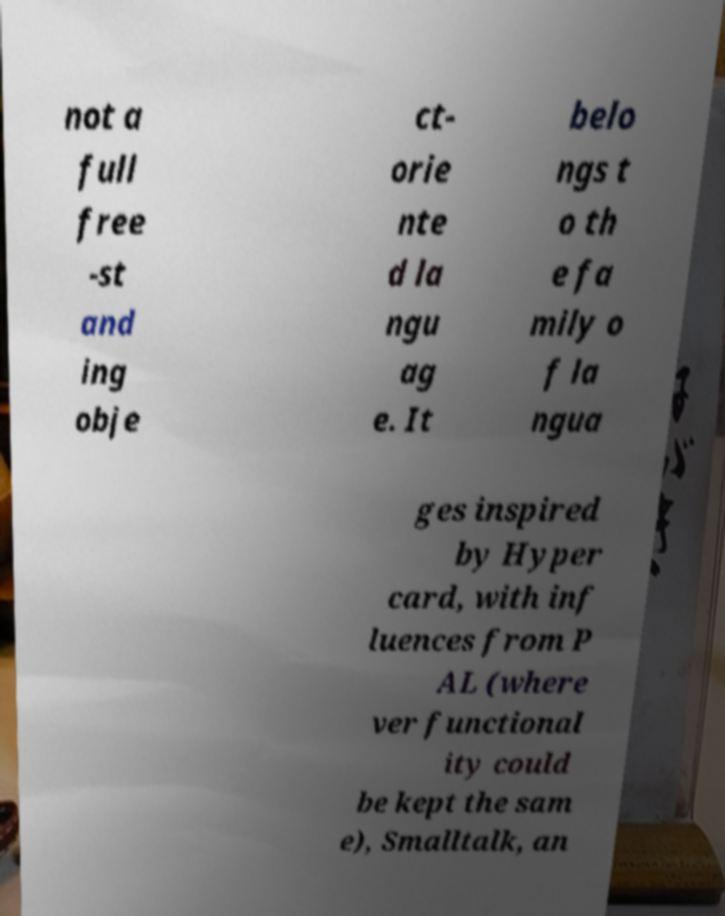Can you read and provide the text displayed in the image?This photo seems to have some interesting text. Can you extract and type it out for me? not a full free -st and ing obje ct- orie nte d la ngu ag e. It belo ngs t o th e fa mily o f la ngua ges inspired by Hyper card, with inf luences from P AL (where ver functional ity could be kept the sam e), Smalltalk, an 